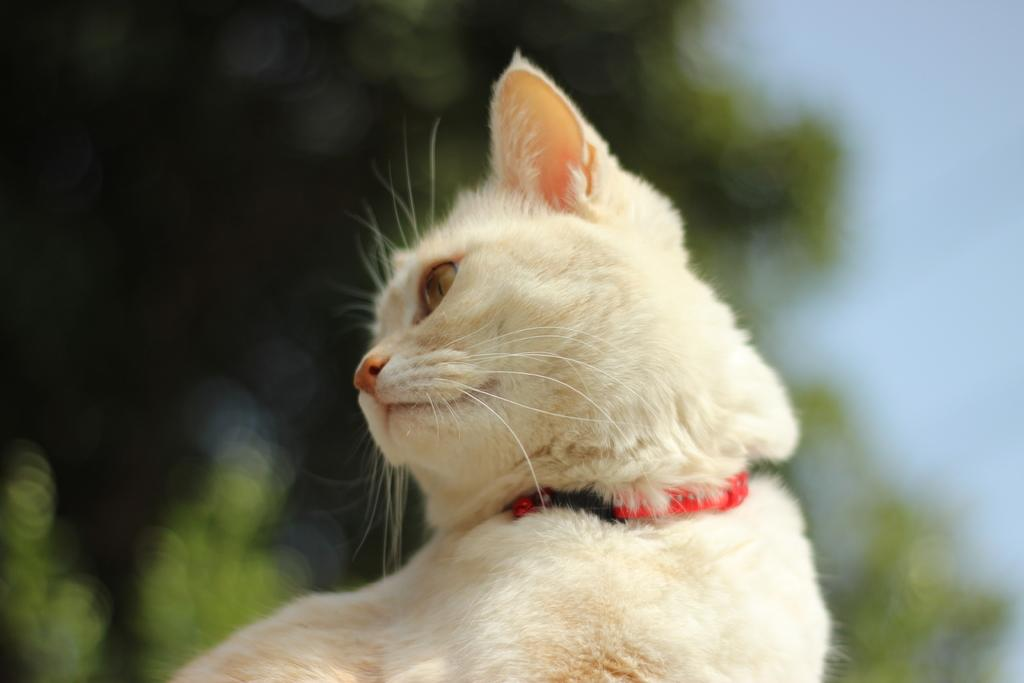What type of animal is in the picture? There is a cat in the picture. Can you describe the cat's appearance? The cat has a red color belt around its neck. What can be seen in the background of the picture? There are trees visible in the background of the picture. How would you describe the weather in the picture? The sky appears to be cloudy in the picture. What type of prison is the cat in charge of in the image? There is no prison or any indication of the cat being in charge of one in the image. 